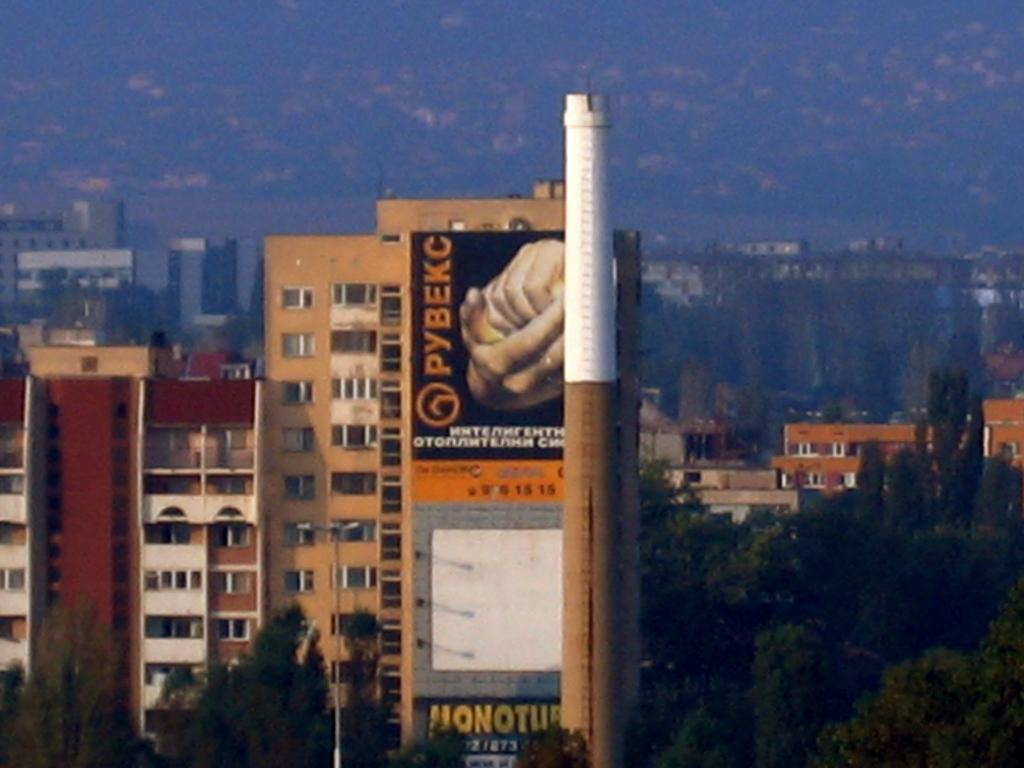What types of structures are located in the foreground area of the image? There are buildings, trees, a tower, and a poster in the foreground area of the image. Can you describe the tower in the foreground area of the image? The tower is a tall structure that stands out among the other elements in the foreground area. What else can be seen in the foreground area of the image? There are buildings and trees in the foreground area of the image. What is visible in the background of the image? There are buildings in the background of the image. What type of yoke can be seen in the image? There is no yoke present in the image. What type of flesh can be seen on the poster in the image? There is no flesh depicted on the poster in the image. 